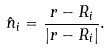Convert formula to latex. <formula><loc_0><loc_0><loc_500><loc_500>\hat { n } _ { i } = \frac { { r } - { R } _ { i } } { | { r } - { R } _ { i } | } .</formula> 